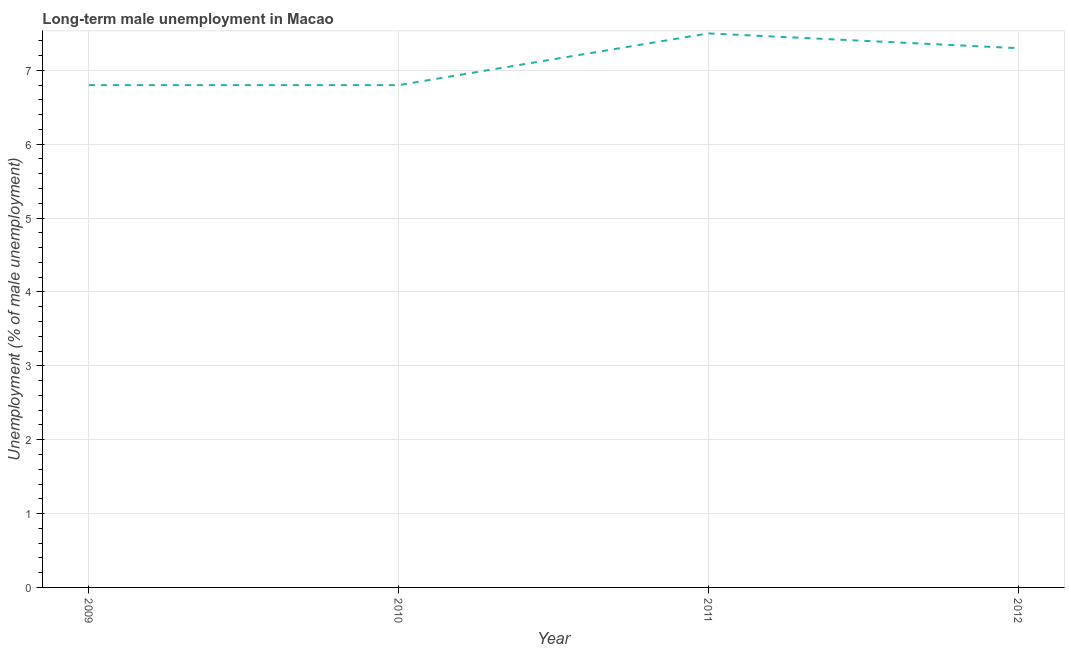What is the long-term male unemployment in 2010?
Give a very brief answer. 6.8. Across all years, what is the maximum long-term male unemployment?
Your answer should be compact. 7.5. Across all years, what is the minimum long-term male unemployment?
Your response must be concise. 6.8. In which year was the long-term male unemployment minimum?
Give a very brief answer. 2009. What is the sum of the long-term male unemployment?
Give a very brief answer. 28.4. What is the average long-term male unemployment per year?
Your response must be concise. 7.1. What is the median long-term male unemployment?
Offer a terse response. 7.05. Do a majority of the years between 2009 and 2010 (inclusive) have long-term male unemployment greater than 6.8 %?
Your response must be concise. Yes. What is the ratio of the long-term male unemployment in 2010 to that in 2012?
Make the answer very short. 0.93. What is the difference between the highest and the second highest long-term male unemployment?
Provide a short and direct response. 0.2. What is the difference between the highest and the lowest long-term male unemployment?
Make the answer very short. 0.7. In how many years, is the long-term male unemployment greater than the average long-term male unemployment taken over all years?
Make the answer very short. 2. Does the long-term male unemployment monotonically increase over the years?
Your response must be concise. No. How many lines are there?
Your answer should be compact. 1. What is the difference between two consecutive major ticks on the Y-axis?
Your response must be concise. 1. Are the values on the major ticks of Y-axis written in scientific E-notation?
Give a very brief answer. No. Does the graph contain any zero values?
Provide a short and direct response. No. What is the title of the graph?
Your answer should be very brief. Long-term male unemployment in Macao. What is the label or title of the X-axis?
Give a very brief answer. Year. What is the label or title of the Y-axis?
Your answer should be very brief. Unemployment (% of male unemployment). What is the Unemployment (% of male unemployment) in 2009?
Keep it short and to the point. 6.8. What is the Unemployment (% of male unemployment) of 2010?
Give a very brief answer. 6.8. What is the Unemployment (% of male unemployment) in 2011?
Ensure brevity in your answer.  7.5. What is the Unemployment (% of male unemployment) in 2012?
Offer a terse response. 7.3. What is the difference between the Unemployment (% of male unemployment) in 2009 and 2010?
Provide a short and direct response. 0. What is the difference between the Unemployment (% of male unemployment) in 2010 and 2011?
Make the answer very short. -0.7. What is the difference between the Unemployment (% of male unemployment) in 2010 and 2012?
Keep it short and to the point. -0.5. What is the ratio of the Unemployment (% of male unemployment) in 2009 to that in 2011?
Keep it short and to the point. 0.91. What is the ratio of the Unemployment (% of male unemployment) in 2009 to that in 2012?
Ensure brevity in your answer.  0.93. What is the ratio of the Unemployment (% of male unemployment) in 2010 to that in 2011?
Offer a very short reply. 0.91. What is the ratio of the Unemployment (% of male unemployment) in 2010 to that in 2012?
Provide a succinct answer. 0.93. What is the ratio of the Unemployment (% of male unemployment) in 2011 to that in 2012?
Ensure brevity in your answer.  1.03. 